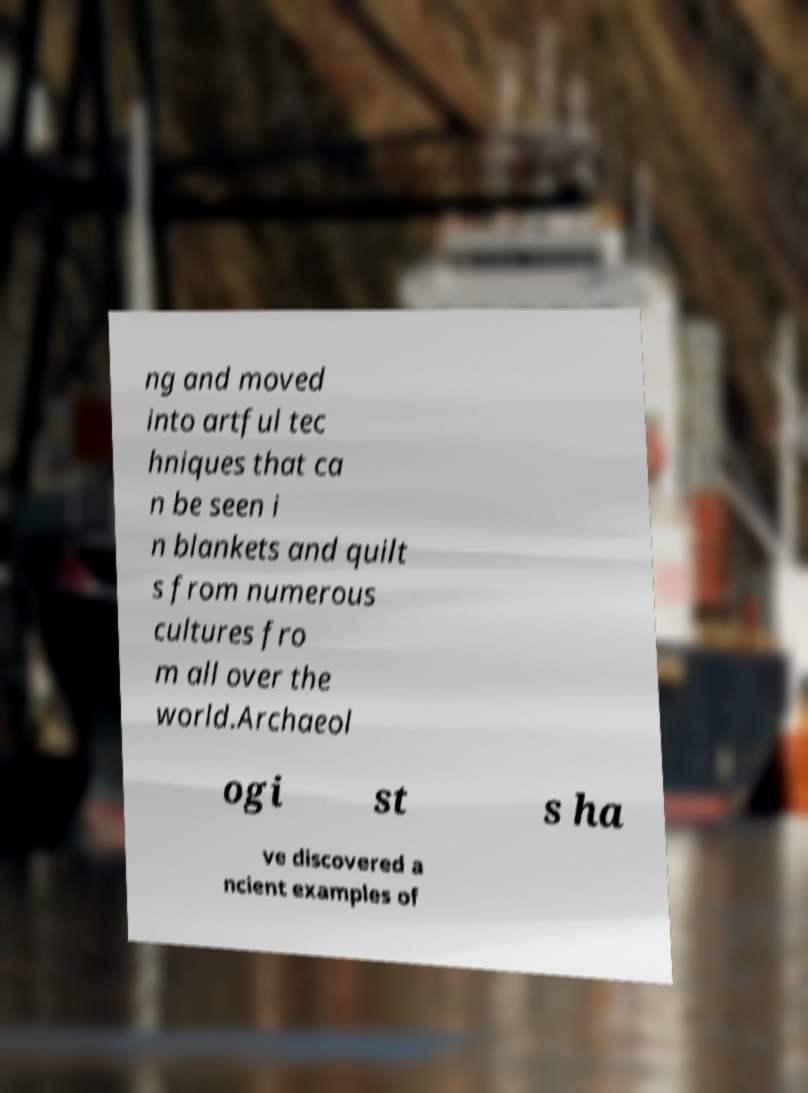Can you read and provide the text displayed in the image?This photo seems to have some interesting text. Can you extract and type it out for me? ng and moved into artful tec hniques that ca n be seen i n blankets and quilt s from numerous cultures fro m all over the world.Archaeol ogi st s ha ve discovered a ncient examples of 